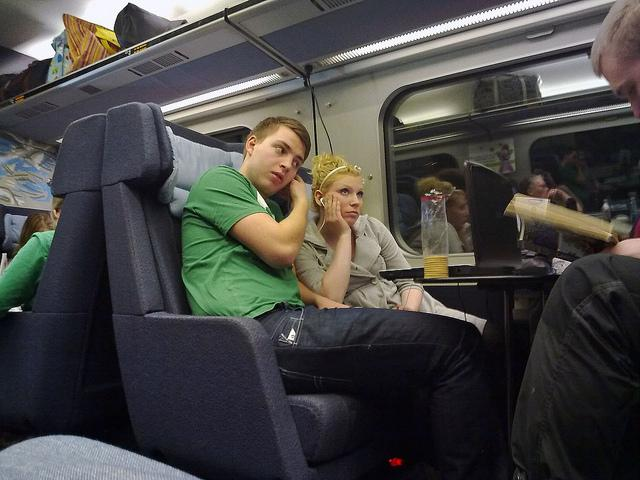What are the two young people doing with the headphones?

Choices:
A) listening
B) pulling
C) gaming
D) fighting listening 